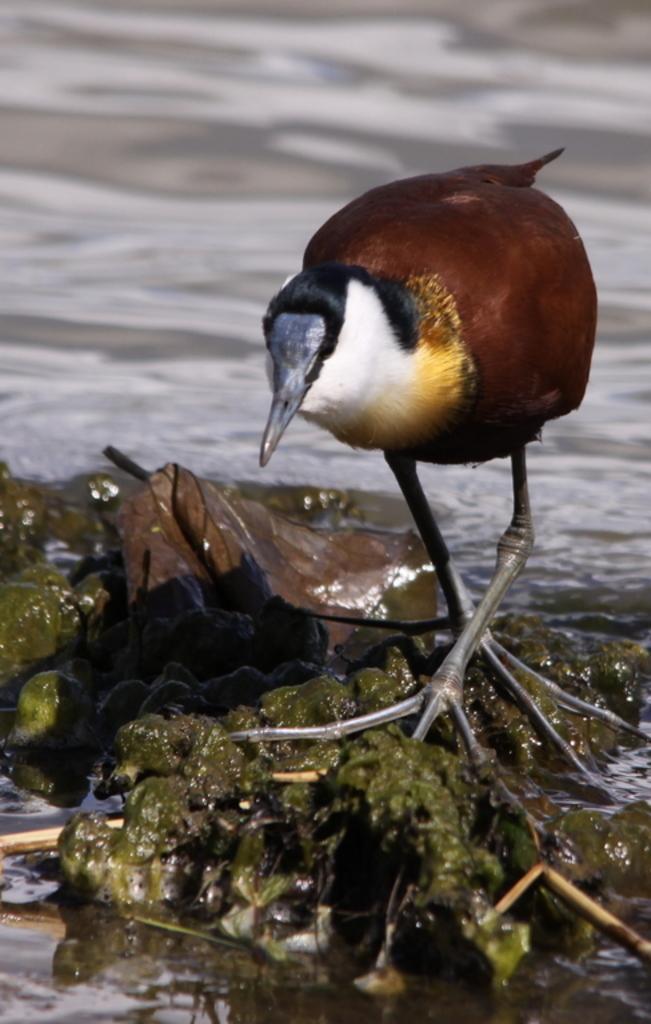Please provide a concise description of this image. In this picture we can see a bird is standing, there is something present at the bottom, in the background we can see water. 